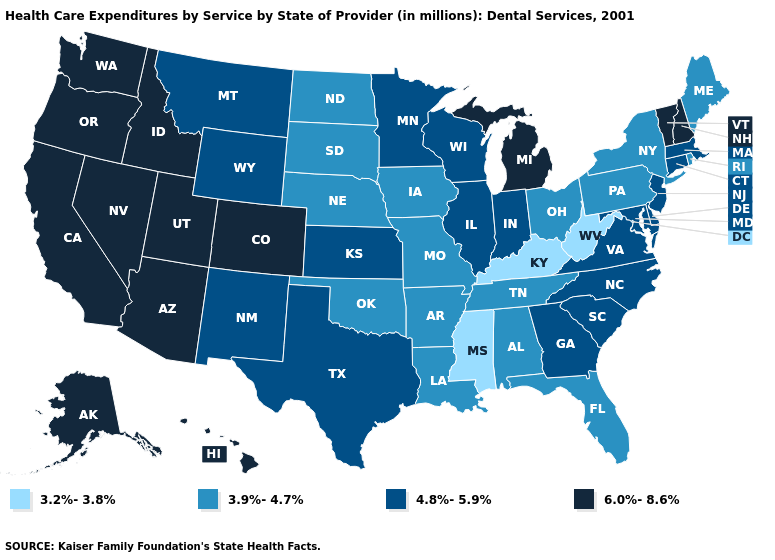Does the first symbol in the legend represent the smallest category?
Quick response, please. Yes. What is the value of Maryland?
Keep it brief. 4.8%-5.9%. What is the lowest value in the USA?
Give a very brief answer. 3.2%-3.8%. Name the states that have a value in the range 3.2%-3.8%?
Keep it brief. Kentucky, Mississippi, West Virginia. What is the value of West Virginia?
Concise answer only. 3.2%-3.8%. Name the states that have a value in the range 4.8%-5.9%?
Quick response, please. Connecticut, Delaware, Georgia, Illinois, Indiana, Kansas, Maryland, Massachusetts, Minnesota, Montana, New Jersey, New Mexico, North Carolina, South Carolina, Texas, Virginia, Wisconsin, Wyoming. Which states have the lowest value in the Northeast?
Short answer required. Maine, New York, Pennsylvania, Rhode Island. Name the states that have a value in the range 4.8%-5.9%?
Short answer required. Connecticut, Delaware, Georgia, Illinois, Indiana, Kansas, Maryland, Massachusetts, Minnesota, Montana, New Jersey, New Mexico, North Carolina, South Carolina, Texas, Virginia, Wisconsin, Wyoming. Name the states that have a value in the range 3.9%-4.7%?
Answer briefly. Alabama, Arkansas, Florida, Iowa, Louisiana, Maine, Missouri, Nebraska, New York, North Dakota, Ohio, Oklahoma, Pennsylvania, Rhode Island, South Dakota, Tennessee. What is the highest value in the USA?
Write a very short answer. 6.0%-8.6%. Name the states that have a value in the range 3.9%-4.7%?
Short answer required. Alabama, Arkansas, Florida, Iowa, Louisiana, Maine, Missouri, Nebraska, New York, North Dakota, Ohio, Oklahoma, Pennsylvania, Rhode Island, South Dakota, Tennessee. Does Minnesota have the lowest value in the MidWest?
Write a very short answer. No. What is the lowest value in the South?
Keep it brief. 3.2%-3.8%. Which states have the lowest value in the USA?
Be succinct. Kentucky, Mississippi, West Virginia. Does North Carolina have the lowest value in the USA?
Give a very brief answer. No. 